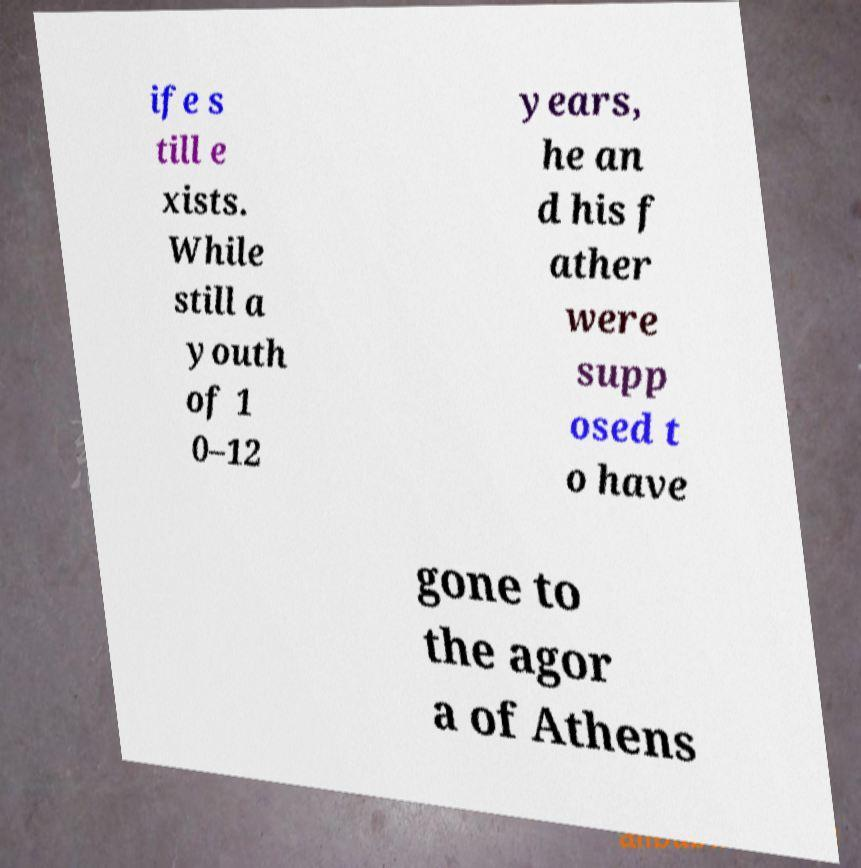Can you read and provide the text displayed in the image?This photo seems to have some interesting text. Can you extract and type it out for me? ife s till e xists. While still a youth of 1 0–12 years, he an d his f ather were supp osed t o have gone to the agor a of Athens 